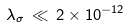Convert formula to latex. <formula><loc_0><loc_0><loc_500><loc_500>\lambda _ { \sigma } \, \ll \, 2 \times 1 0 ^ { - 1 2 }</formula> 